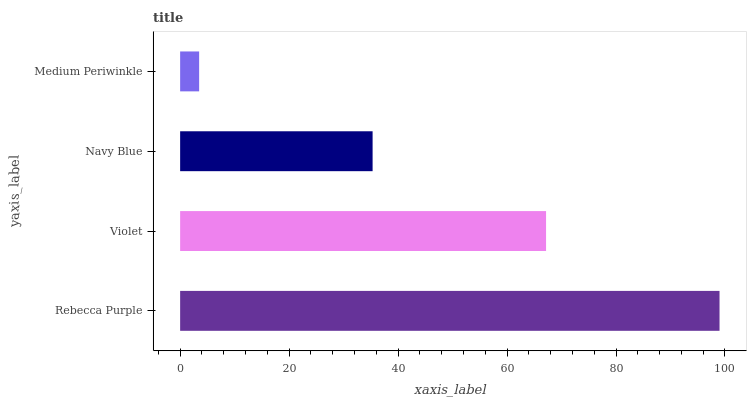Is Medium Periwinkle the minimum?
Answer yes or no. Yes. Is Rebecca Purple the maximum?
Answer yes or no. Yes. Is Violet the minimum?
Answer yes or no. No. Is Violet the maximum?
Answer yes or no. No. Is Rebecca Purple greater than Violet?
Answer yes or no. Yes. Is Violet less than Rebecca Purple?
Answer yes or no. Yes. Is Violet greater than Rebecca Purple?
Answer yes or no. No. Is Rebecca Purple less than Violet?
Answer yes or no. No. Is Violet the high median?
Answer yes or no. Yes. Is Navy Blue the low median?
Answer yes or no. Yes. Is Rebecca Purple the high median?
Answer yes or no. No. Is Violet the low median?
Answer yes or no. No. 